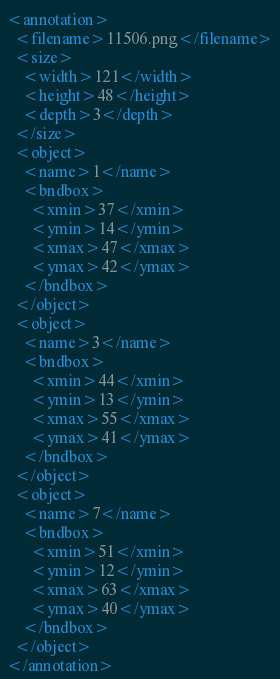<code> <loc_0><loc_0><loc_500><loc_500><_XML_><annotation>
  <filename>11506.png</filename>
  <size>
    <width>121</width>
    <height>48</height>
    <depth>3</depth>
  </size>
  <object>
    <name>1</name>
    <bndbox>
      <xmin>37</xmin>
      <ymin>14</ymin>
      <xmax>47</xmax>
      <ymax>42</ymax>
    </bndbox>
  </object>
  <object>
    <name>3</name>
    <bndbox>
      <xmin>44</xmin>
      <ymin>13</ymin>
      <xmax>55</xmax>
      <ymax>41</ymax>
    </bndbox>
  </object>
  <object>
    <name>7</name>
    <bndbox>
      <xmin>51</xmin>
      <ymin>12</ymin>
      <xmax>63</xmax>
      <ymax>40</ymax>
    </bndbox>
  </object>
</annotation>
</code> 